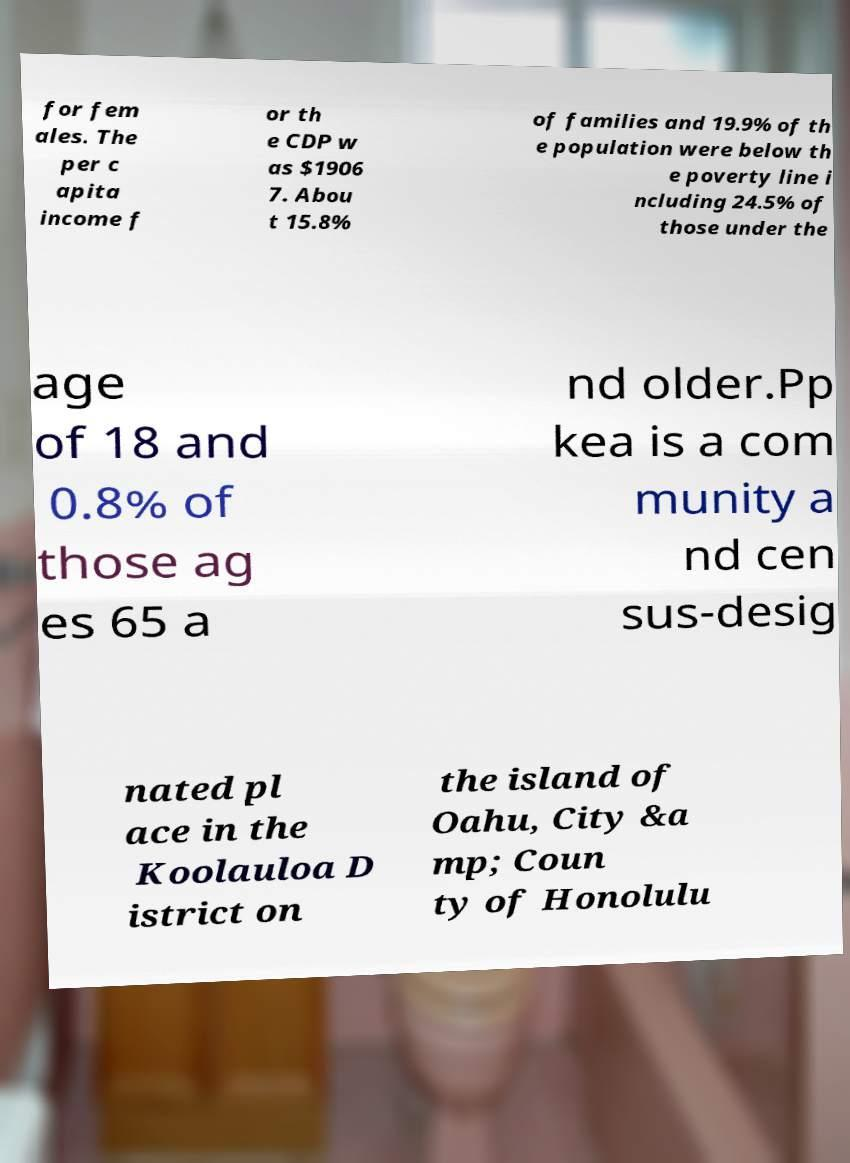There's text embedded in this image that I need extracted. Can you transcribe it verbatim? for fem ales. The per c apita income f or th e CDP w as $1906 7. Abou t 15.8% of families and 19.9% of th e population were below th e poverty line i ncluding 24.5% of those under the age of 18 and 0.8% of those ag es 65 a nd older.Pp kea is a com munity a nd cen sus-desig nated pl ace in the Koolauloa D istrict on the island of Oahu, City &a mp; Coun ty of Honolulu 